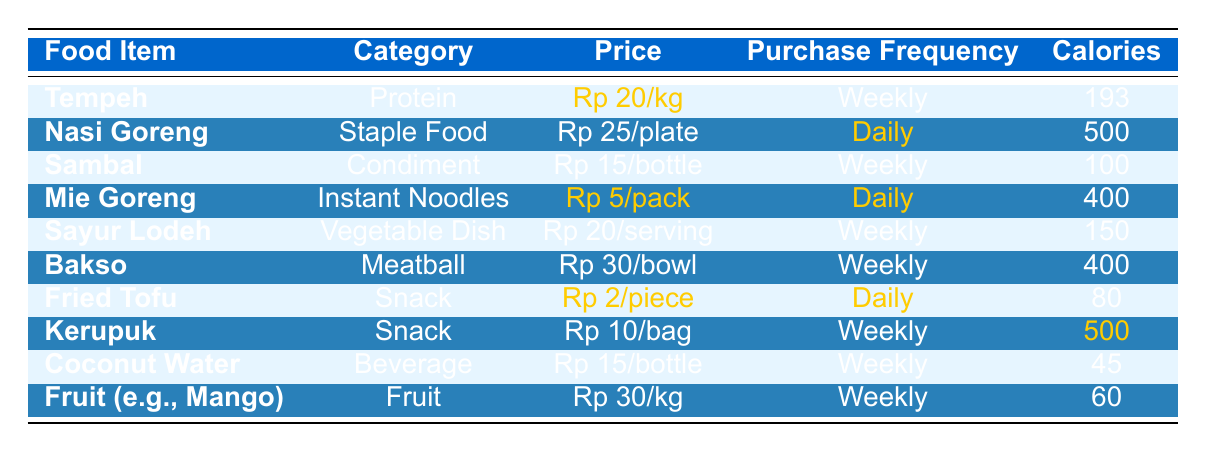What is the price per kg of Tempeh? The table shows that the price of Tempeh is highlighted as Rp 20/kg.
Answer: Rp 20/kg How often is Nasi Goreng purchased? According to the table, Nasi Goreng has a purchase frequency of highlighted "Daily."
Answer: Daily Which food item has the highest calories per serving? The table indicates that Nasi Goreng has 500 calories per plate, which is the highest compared to other food items.
Answer: Nasi Goreng What is the total price for buying one pack of Mie Goreng and one piece of Fried Tofu? The price of Mie Goreng is Rp 5/pack and Fried Tofu is Rp 2/piece. Adding those together: 5 + 2 = Rp 7.
Answer: Rp 7 Is Bakso purchased daily? The frequency of Bakso purchases is stated as "Weekly" in the table.
Answer: No Calculate the average calories for food items purchased daily. The daily food items are Nasi Goreng (500 calories), Mie Goreng (400 calories), and Fried Tofu (80 calories). Their total is 500 + 400 + 80 = 980. There are 3 items, so the average is 980 / 3 ≈ 326.67.
Answer: 326.67 What is the nutritional value of one serving of Sayur Lodeh? The table lists Sayur Lodeh as having 150 calories, 5g protein, 7g fat, and 15g carbohydrates per serving.
Answer: 150 calories, 5g protein, 7g fat, 15g carbohydrates Which food item costs less than Rp 10? The table shows that the only item under Rp 10 is Fried Tofu at Rp 2/piece.
Answer: Fried Tofu How many calories do you get from a bottle of Coconut Water? According to the table, a bottle of Coconut Water contains 45 calories.
Answer: 45 calories Which food item has both high protein and low price? Tempeh contains 19g protein and costs Rp 20/kg, making it a cost-effective high-protein option.
Answer: Tempeh 